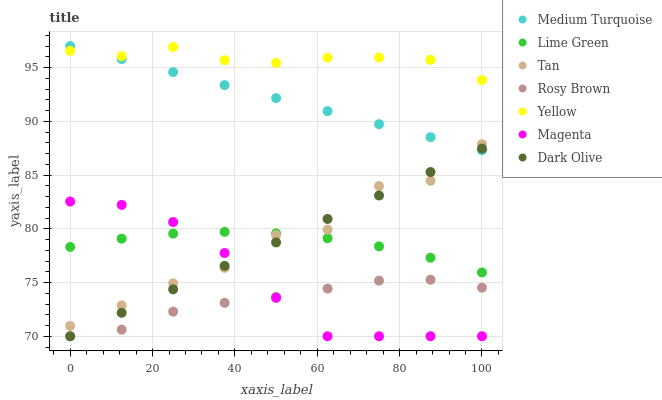Does Rosy Brown have the minimum area under the curve?
Answer yes or no. Yes. Does Yellow have the maximum area under the curve?
Answer yes or no. Yes. Does Yellow have the minimum area under the curve?
Answer yes or no. No. Does Rosy Brown have the maximum area under the curve?
Answer yes or no. No. Is Medium Turquoise the smoothest?
Answer yes or no. Yes. Is Tan the roughest?
Answer yes or no. Yes. Is Rosy Brown the smoothest?
Answer yes or no. No. Is Rosy Brown the roughest?
Answer yes or no. No. Does Dark Olive have the lowest value?
Answer yes or no. Yes. Does Yellow have the lowest value?
Answer yes or no. No. Does Medium Turquoise have the highest value?
Answer yes or no. Yes. Does Yellow have the highest value?
Answer yes or no. No. Is Rosy Brown less than Medium Turquoise?
Answer yes or no. Yes. Is Yellow greater than Dark Olive?
Answer yes or no. Yes. Does Magenta intersect Rosy Brown?
Answer yes or no. Yes. Is Magenta less than Rosy Brown?
Answer yes or no. No. Is Magenta greater than Rosy Brown?
Answer yes or no. No. Does Rosy Brown intersect Medium Turquoise?
Answer yes or no. No. 